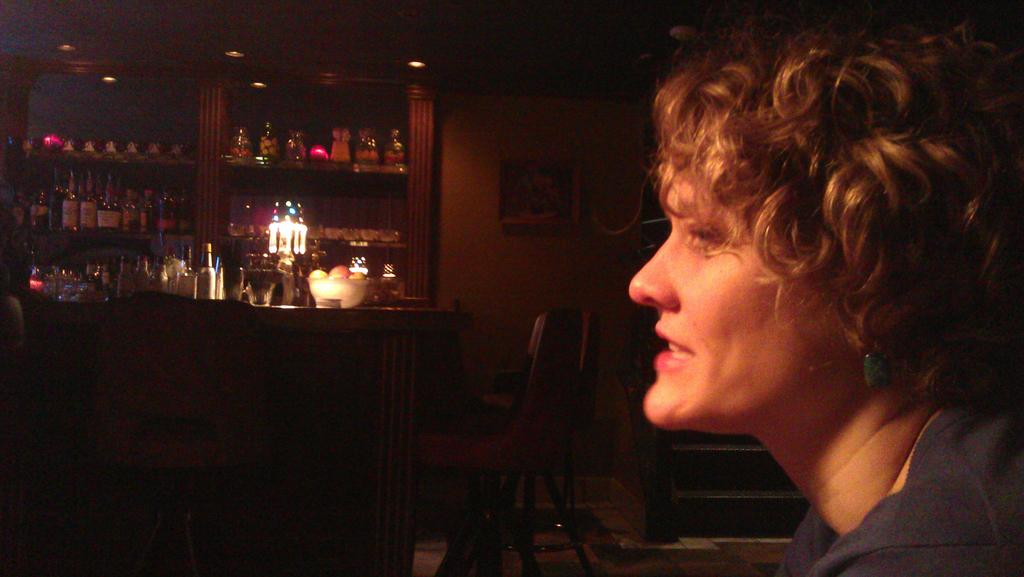Who is present in the image? There is a woman in the image. What architectural feature can be seen in the image? There are steps in the image. What type of furniture is visible in the image? There are chairs in the image. What is in the bowl that is visible in the image? There is a bowl with fruits in it. What type of storage is present in the image? There are objects in racks in the image. What type of illumination is present in the image? There are lights in the image. What type of decoration is present on the wall in the image? There is a frame on the wall in the image. What type of noise can be heard coming from the battle in the image? There is no battle present in the image, so no noise can be heard from it. 